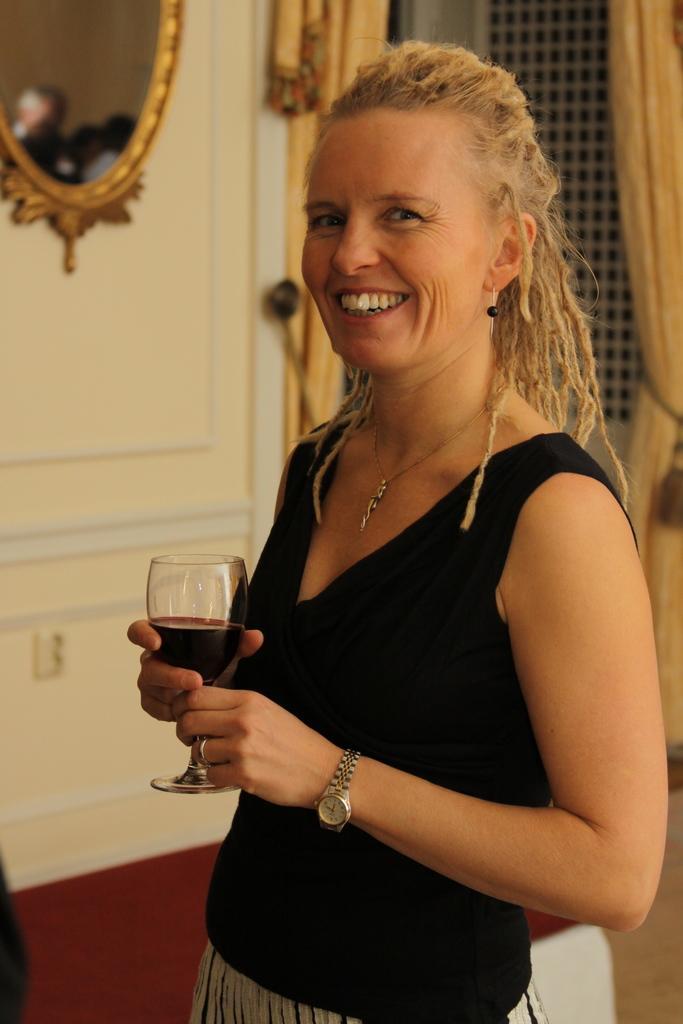Can you describe this image briefly? in this image there is a woman standing at the center,holding a glass of drink. she is wearing a black dress and smiling. behind her there is a mirror and at the right corner there is a curtain. 